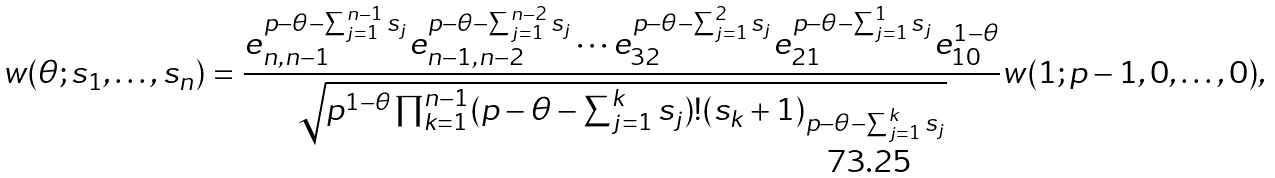<formula> <loc_0><loc_0><loc_500><loc_500>w ( \theta ; s _ { 1 } , \dots , s _ { n } ) = \frac { e _ { n , n - 1 } ^ { p - \theta - \sum _ { j = 1 } ^ { n - 1 } s _ { j } } e _ { n - 1 , n - 2 } ^ { p - \theta - \sum _ { j = 1 } ^ { n - 2 } s _ { j } } \cdots e _ { 3 2 } ^ { p - \theta - \sum _ { j = 1 } ^ { 2 } s _ { j } } e _ { 2 1 } ^ { p - \theta - \sum _ { j = 1 } ^ { 1 } s _ { j } } e _ { 1 0 } ^ { 1 - \theta } } { \sqrt { p ^ { 1 - \theta } \prod _ { k = 1 } ^ { n - 1 } ( p - \theta - \sum _ { j = 1 } ^ { k } s _ { j } ) ! ( s _ { k } + 1 ) _ { p - \theta - \sum _ { j = 1 } ^ { k } s _ { j } } } } w ( 1 ; p - 1 , 0 , \dots , 0 ) ,</formula> 